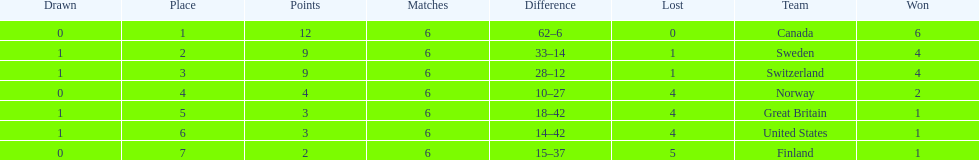Which country finished below the united states? Finland. 